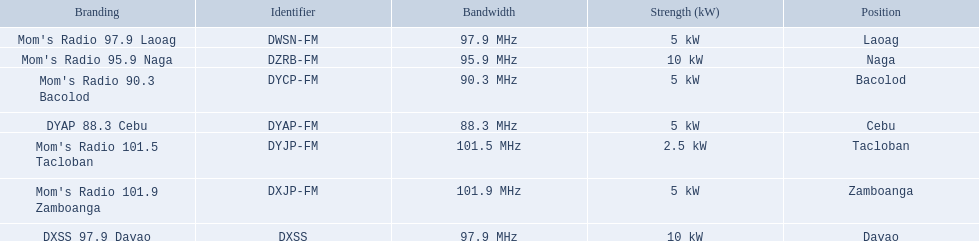What are the frequencies for radios of dyap-fm? 97.9 MHz, 95.9 MHz, 90.3 MHz, 88.3 MHz, 101.5 MHz, 101.9 MHz, 97.9 MHz. What is the lowest frequency? 88.3 MHz. Which radio has this frequency? DYAP 88.3 Cebu. 